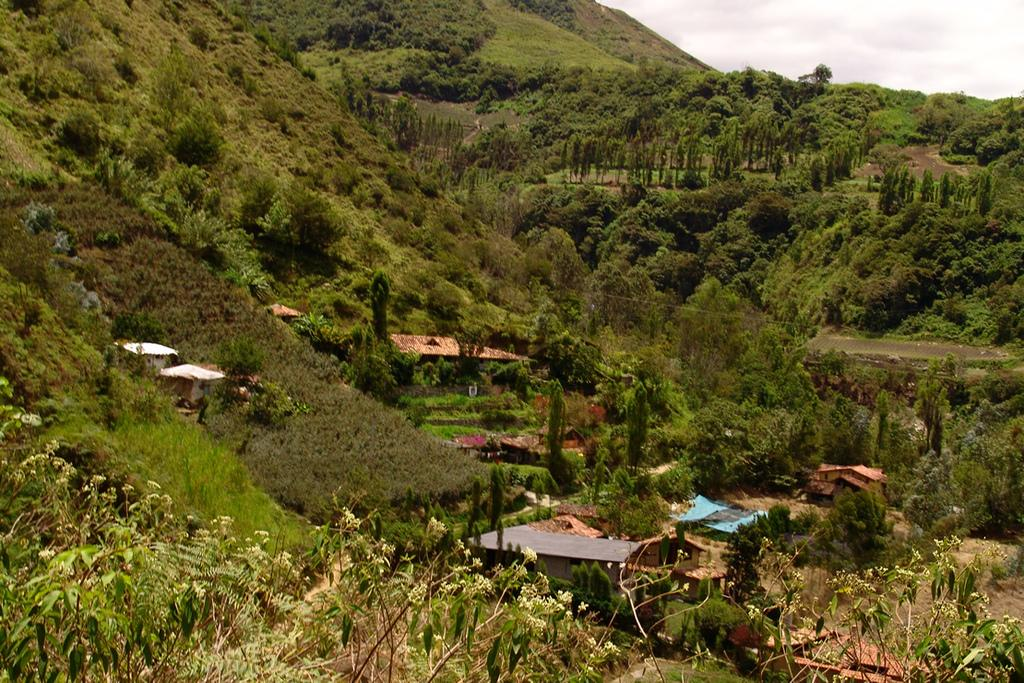What type of structures are located in the center of the image? There are houses in the center of the image. What can be seen at the bottom of the image? There are plants, trees, and mountains at the bottom of the image. What is visible at the top of the image? The sky is visible at the top of the image. What type of destruction can be seen in the image? There is no destruction present in the image. 